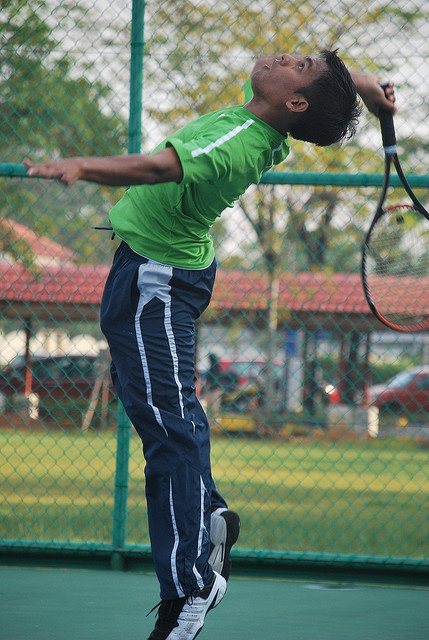Describe the objects in this image and their specific colors. I can see people in gray, black, navy, darkgreen, and green tones, tennis racket in gray, darkgray, tan, and black tones, car in gray, teal, and black tones, car in gray, maroon, darkgray, and teal tones, and car in gray and darkgray tones in this image. 